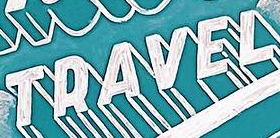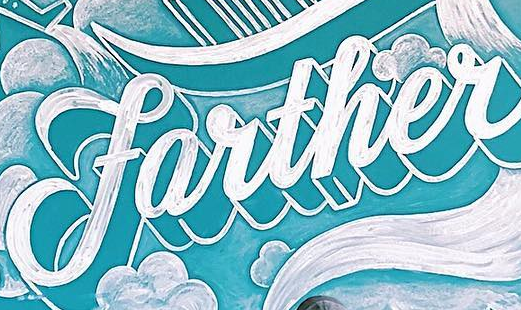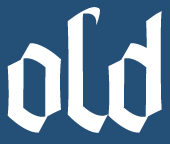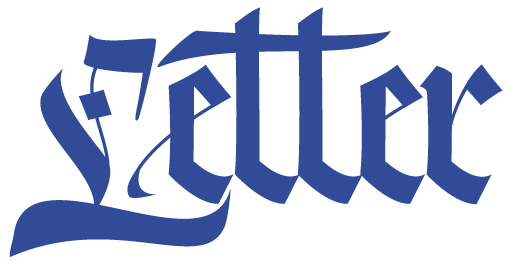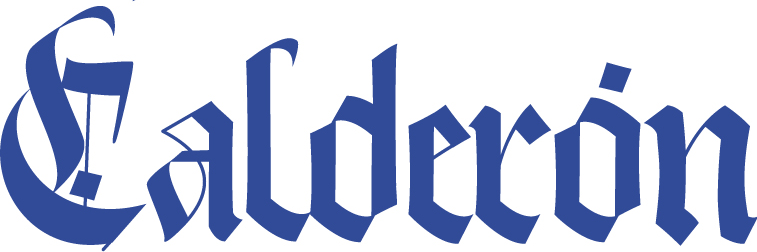Read the text content from these images in order, separated by a semicolon. TRAVEL; farther; old; Letter; Calderón 